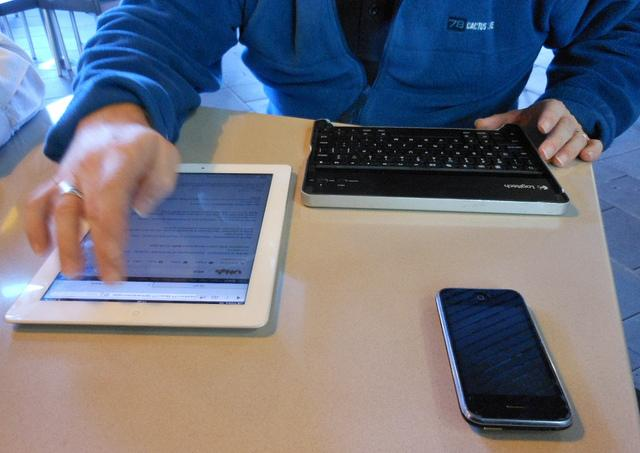Why is he touching the screen?

Choices:
A) cleaning
B) navigating
C) massaging
D) taking fingerprint navigating 